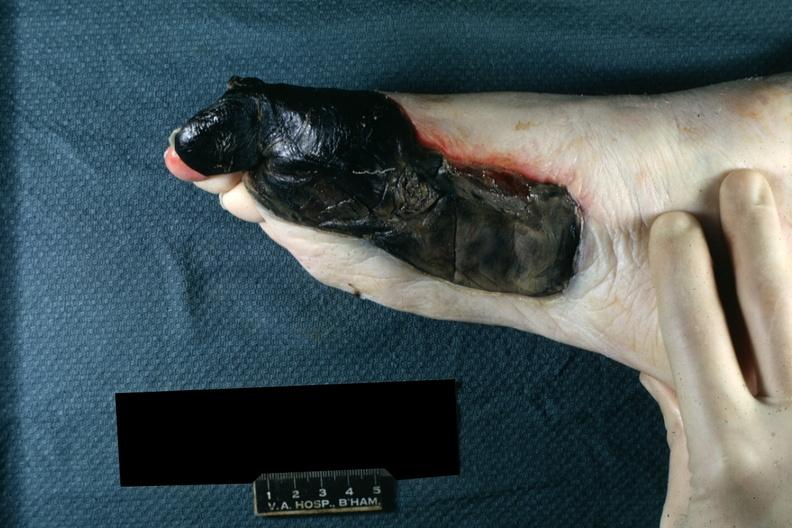does this image show well demarcated gangrenous necrosis medial aspect left foot?
Answer the question using a single word or phrase. Yes 